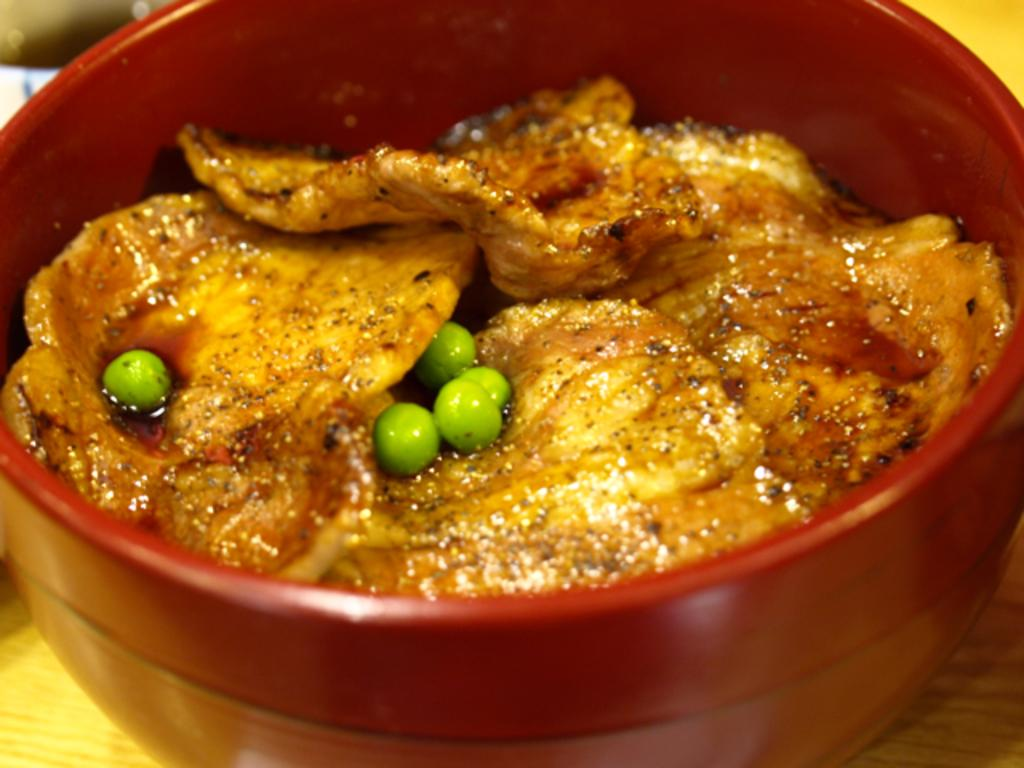What is in the bowl that is visible in the image? There is food in a bowl in the image. What type of furniture is present in the image? There is a table visible in the image. What statement can be made about the texture of the underwear in the image? There is no underwear present in the image, so it is not possible to make any statements about its texture. 